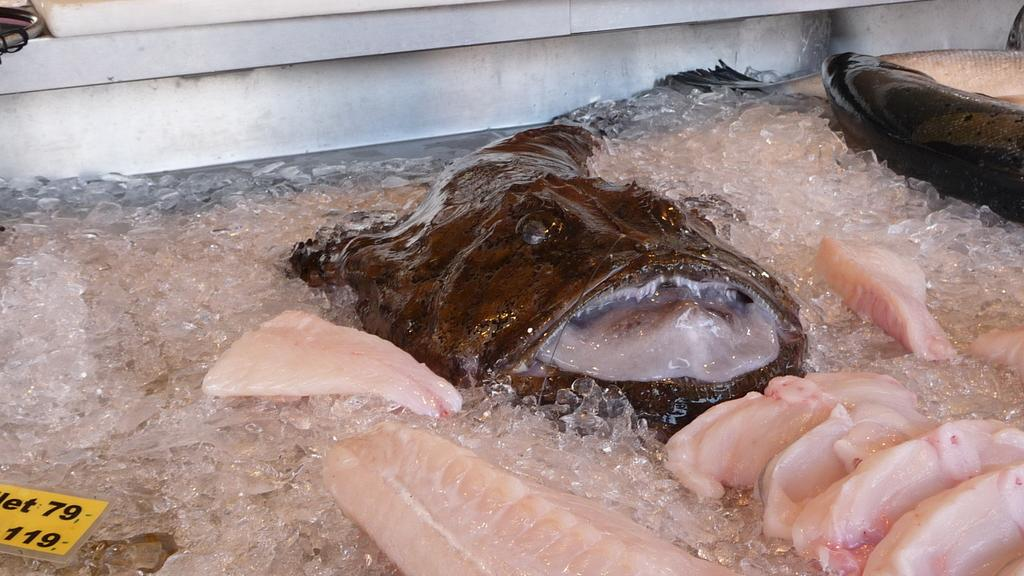What is the main subject in the center of the image? There is a fish in the center of the image. Are there any other fish visible in the image? Yes, there is another fish in the top right side of the image. What is the surrounding environment like in the image? There is ice around the area of the image. What type of dog can be seen playing with the band in the image? There is no dog or band present in the image; it features two fish and ice. How many legs does the fish in the top right side of the image have? Fish do not have legs, so this question cannot be answered based on the information provided. 